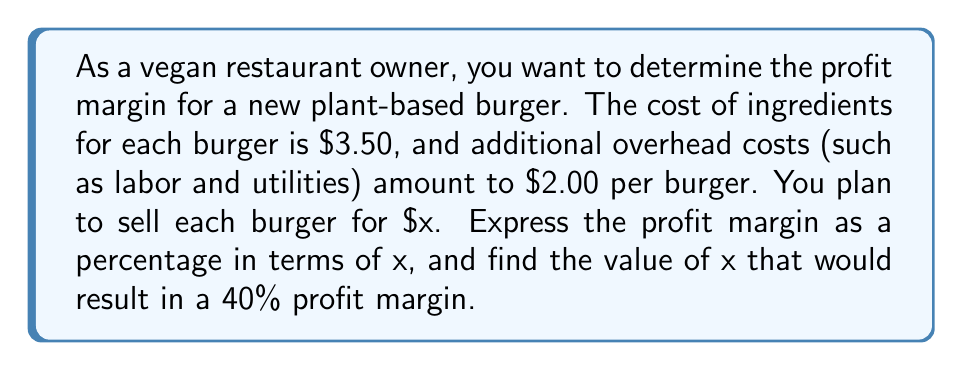Help me with this question. Let's approach this step-by-step:

1. Define the variables:
   $x$ = selling price of the burger
   $3.50$ = cost of ingredients
   $2.00$ = overhead costs per burger

2. Calculate the total cost per burger:
   Total cost = $3.50 + $2.00 = $5.50

3. Express the profit per burger:
   Profit = Selling price - Total cost
   Profit = $x - $5.50

4. The profit margin formula is:
   Profit margin = $\frac{\text{Profit}}{\text{Selling price}} \times 100\%$

5. Substitute the expressions:
   Profit margin = $\frac{x - 5.50}{x} \times 100\%$

6. To find x for a 40% profit margin, set up the equation:
   $\frac{x - 5.50}{x} = 0.40$

7. Solve the equation:
   $x - 5.50 = 0.40x$
   $x - 0.40x = 5.50$
   $0.60x = 5.50$
   $x = \frac{5.50}{0.60} = 9.1666...$

8. Round to a practical price point:
   $x \approx $9.17$
Answer: The profit margin as a percentage in terms of x is:

$$\text{Profit margin} = \frac{x - 5.50}{x} \times 100\%$$

The selling price x that results in a 40% profit margin is approximately $9.17. 